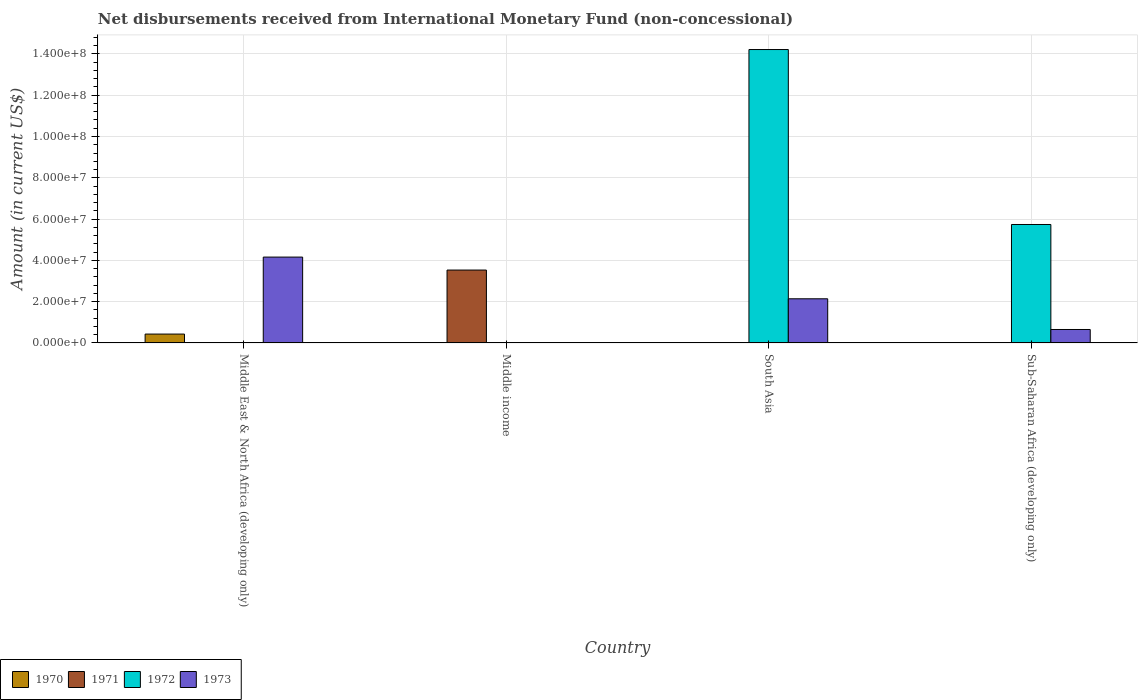Are the number of bars per tick equal to the number of legend labels?
Give a very brief answer. No. Are the number of bars on each tick of the X-axis equal?
Your response must be concise. No. How many bars are there on the 3rd tick from the left?
Your response must be concise. 2. What is the label of the 1st group of bars from the left?
Make the answer very short. Middle East & North Africa (developing only). Across all countries, what is the maximum amount of disbursements received from International Monetary Fund in 1970?
Make the answer very short. 4.30e+06. Across all countries, what is the minimum amount of disbursements received from International Monetary Fund in 1973?
Provide a succinct answer. 0. What is the total amount of disbursements received from International Monetary Fund in 1970 in the graph?
Provide a short and direct response. 4.30e+06. What is the difference between the amount of disbursements received from International Monetary Fund in 1972 in South Asia and that in Sub-Saharan Africa (developing only)?
Keep it short and to the point. 8.48e+07. What is the difference between the amount of disbursements received from International Monetary Fund in 1970 in South Asia and the amount of disbursements received from International Monetary Fund in 1972 in Middle East & North Africa (developing only)?
Your answer should be compact. 0. What is the average amount of disbursements received from International Monetary Fund in 1972 per country?
Your answer should be very brief. 4.99e+07. What is the difference between the amount of disbursements received from International Monetary Fund of/in 1973 and amount of disbursements received from International Monetary Fund of/in 1970 in Middle East & North Africa (developing only)?
Give a very brief answer. 3.73e+07. What is the ratio of the amount of disbursements received from International Monetary Fund in 1973 in Middle East & North Africa (developing only) to that in Sub-Saharan Africa (developing only)?
Keep it short and to the point. 6.39. What is the difference between the highest and the second highest amount of disbursements received from International Monetary Fund in 1973?
Provide a short and direct response. 3.51e+07. What is the difference between the highest and the lowest amount of disbursements received from International Monetary Fund in 1970?
Your answer should be very brief. 4.30e+06. Is it the case that in every country, the sum of the amount of disbursements received from International Monetary Fund in 1970 and amount of disbursements received from International Monetary Fund in 1973 is greater than the sum of amount of disbursements received from International Monetary Fund in 1972 and amount of disbursements received from International Monetary Fund in 1971?
Your answer should be compact. No. Is it the case that in every country, the sum of the amount of disbursements received from International Monetary Fund in 1973 and amount of disbursements received from International Monetary Fund in 1970 is greater than the amount of disbursements received from International Monetary Fund in 1972?
Your answer should be very brief. No. How many bars are there?
Your response must be concise. 7. Are all the bars in the graph horizontal?
Your answer should be very brief. No. What is the difference between two consecutive major ticks on the Y-axis?
Give a very brief answer. 2.00e+07. Where does the legend appear in the graph?
Your answer should be compact. Bottom left. How many legend labels are there?
Your response must be concise. 4. What is the title of the graph?
Offer a terse response. Net disbursements received from International Monetary Fund (non-concessional). Does "1989" appear as one of the legend labels in the graph?
Your answer should be very brief. No. What is the label or title of the X-axis?
Your answer should be very brief. Country. What is the label or title of the Y-axis?
Make the answer very short. Amount (in current US$). What is the Amount (in current US$) of 1970 in Middle East & North Africa (developing only)?
Your answer should be very brief. 4.30e+06. What is the Amount (in current US$) of 1971 in Middle East & North Africa (developing only)?
Give a very brief answer. 0. What is the Amount (in current US$) in 1972 in Middle East & North Africa (developing only)?
Offer a terse response. 0. What is the Amount (in current US$) of 1973 in Middle East & North Africa (developing only)?
Your answer should be very brief. 4.16e+07. What is the Amount (in current US$) in 1970 in Middle income?
Provide a short and direct response. 0. What is the Amount (in current US$) of 1971 in Middle income?
Offer a very short reply. 3.53e+07. What is the Amount (in current US$) of 1973 in Middle income?
Offer a very short reply. 0. What is the Amount (in current US$) of 1972 in South Asia?
Make the answer very short. 1.42e+08. What is the Amount (in current US$) of 1973 in South Asia?
Provide a succinct answer. 2.14e+07. What is the Amount (in current US$) in 1970 in Sub-Saharan Africa (developing only)?
Your answer should be very brief. 0. What is the Amount (in current US$) of 1972 in Sub-Saharan Africa (developing only)?
Make the answer very short. 5.74e+07. What is the Amount (in current US$) in 1973 in Sub-Saharan Africa (developing only)?
Provide a short and direct response. 6.51e+06. Across all countries, what is the maximum Amount (in current US$) in 1970?
Ensure brevity in your answer.  4.30e+06. Across all countries, what is the maximum Amount (in current US$) in 1971?
Your answer should be very brief. 3.53e+07. Across all countries, what is the maximum Amount (in current US$) in 1972?
Keep it short and to the point. 1.42e+08. Across all countries, what is the maximum Amount (in current US$) of 1973?
Provide a short and direct response. 4.16e+07. Across all countries, what is the minimum Amount (in current US$) of 1970?
Keep it short and to the point. 0. Across all countries, what is the minimum Amount (in current US$) of 1972?
Make the answer very short. 0. Across all countries, what is the minimum Amount (in current US$) of 1973?
Your response must be concise. 0. What is the total Amount (in current US$) of 1970 in the graph?
Make the answer very short. 4.30e+06. What is the total Amount (in current US$) in 1971 in the graph?
Offer a very short reply. 3.53e+07. What is the total Amount (in current US$) in 1972 in the graph?
Keep it short and to the point. 2.00e+08. What is the total Amount (in current US$) in 1973 in the graph?
Ensure brevity in your answer.  6.95e+07. What is the difference between the Amount (in current US$) of 1973 in Middle East & North Africa (developing only) and that in South Asia?
Make the answer very short. 2.02e+07. What is the difference between the Amount (in current US$) in 1973 in Middle East & North Africa (developing only) and that in Sub-Saharan Africa (developing only)?
Keep it short and to the point. 3.51e+07. What is the difference between the Amount (in current US$) of 1972 in South Asia and that in Sub-Saharan Africa (developing only)?
Make the answer very short. 8.48e+07. What is the difference between the Amount (in current US$) in 1973 in South Asia and that in Sub-Saharan Africa (developing only)?
Make the answer very short. 1.49e+07. What is the difference between the Amount (in current US$) in 1970 in Middle East & North Africa (developing only) and the Amount (in current US$) in 1971 in Middle income?
Your answer should be compact. -3.10e+07. What is the difference between the Amount (in current US$) in 1970 in Middle East & North Africa (developing only) and the Amount (in current US$) in 1972 in South Asia?
Provide a short and direct response. -1.38e+08. What is the difference between the Amount (in current US$) in 1970 in Middle East & North Africa (developing only) and the Amount (in current US$) in 1973 in South Asia?
Offer a very short reply. -1.71e+07. What is the difference between the Amount (in current US$) in 1970 in Middle East & North Africa (developing only) and the Amount (in current US$) in 1972 in Sub-Saharan Africa (developing only)?
Keep it short and to the point. -5.31e+07. What is the difference between the Amount (in current US$) of 1970 in Middle East & North Africa (developing only) and the Amount (in current US$) of 1973 in Sub-Saharan Africa (developing only)?
Give a very brief answer. -2.21e+06. What is the difference between the Amount (in current US$) of 1971 in Middle income and the Amount (in current US$) of 1972 in South Asia?
Your response must be concise. -1.07e+08. What is the difference between the Amount (in current US$) in 1971 in Middle income and the Amount (in current US$) in 1973 in South Asia?
Keep it short and to the point. 1.39e+07. What is the difference between the Amount (in current US$) of 1971 in Middle income and the Amount (in current US$) of 1972 in Sub-Saharan Africa (developing only)?
Keep it short and to the point. -2.21e+07. What is the difference between the Amount (in current US$) in 1971 in Middle income and the Amount (in current US$) in 1973 in Sub-Saharan Africa (developing only)?
Your answer should be very brief. 2.88e+07. What is the difference between the Amount (in current US$) of 1972 in South Asia and the Amount (in current US$) of 1973 in Sub-Saharan Africa (developing only)?
Make the answer very short. 1.36e+08. What is the average Amount (in current US$) of 1970 per country?
Ensure brevity in your answer.  1.08e+06. What is the average Amount (in current US$) in 1971 per country?
Offer a terse response. 8.83e+06. What is the average Amount (in current US$) of 1972 per country?
Provide a short and direct response. 4.99e+07. What is the average Amount (in current US$) of 1973 per country?
Your answer should be very brief. 1.74e+07. What is the difference between the Amount (in current US$) in 1970 and Amount (in current US$) in 1973 in Middle East & North Africa (developing only)?
Your answer should be very brief. -3.73e+07. What is the difference between the Amount (in current US$) in 1972 and Amount (in current US$) in 1973 in South Asia?
Offer a terse response. 1.21e+08. What is the difference between the Amount (in current US$) of 1972 and Amount (in current US$) of 1973 in Sub-Saharan Africa (developing only)?
Provide a succinct answer. 5.09e+07. What is the ratio of the Amount (in current US$) in 1973 in Middle East & North Africa (developing only) to that in South Asia?
Offer a terse response. 1.94. What is the ratio of the Amount (in current US$) in 1973 in Middle East & North Africa (developing only) to that in Sub-Saharan Africa (developing only)?
Keep it short and to the point. 6.39. What is the ratio of the Amount (in current US$) of 1972 in South Asia to that in Sub-Saharan Africa (developing only)?
Your response must be concise. 2.48. What is the ratio of the Amount (in current US$) of 1973 in South Asia to that in Sub-Saharan Africa (developing only)?
Your answer should be very brief. 3.29. What is the difference between the highest and the second highest Amount (in current US$) of 1973?
Offer a very short reply. 2.02e+07. What is the difference between the highest and the lowest Amount (in current US$) of 1970?
Ensure brevity in your answer.  4.30e+06. What is the difference between the highest and the lowest Amount (in current US$) in 1971?
Offer a terse response. 3.53e+07. What is the difference between the highest and the lowest Amount (in current US$) in 1972?
Keep it short and to the point. 1.42e+08. What is the difference between the highest and the lowest Amount (in current US$) in 1973?
Give a very brief answer. 4.16e+07. 